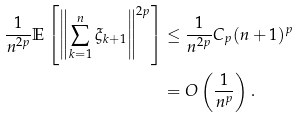<formula> <loc_0><loc_0><loc_500><loc_500>\frac { 1 } { n ^ { 2 p } } \mathbb { E } \left [ \left \| \sum _ { k = 1 } ^ { n } \xi _ { k + 1 } \right \| ^ { 2 p } \right ] & \leq \frac { 1 } { n ^ { 2 p } } C _ { p } ( n + 1 ) ^ { p } \\ & = O \left ( \frac { 1 } { n ^ { p } } \right ) .</formula> 